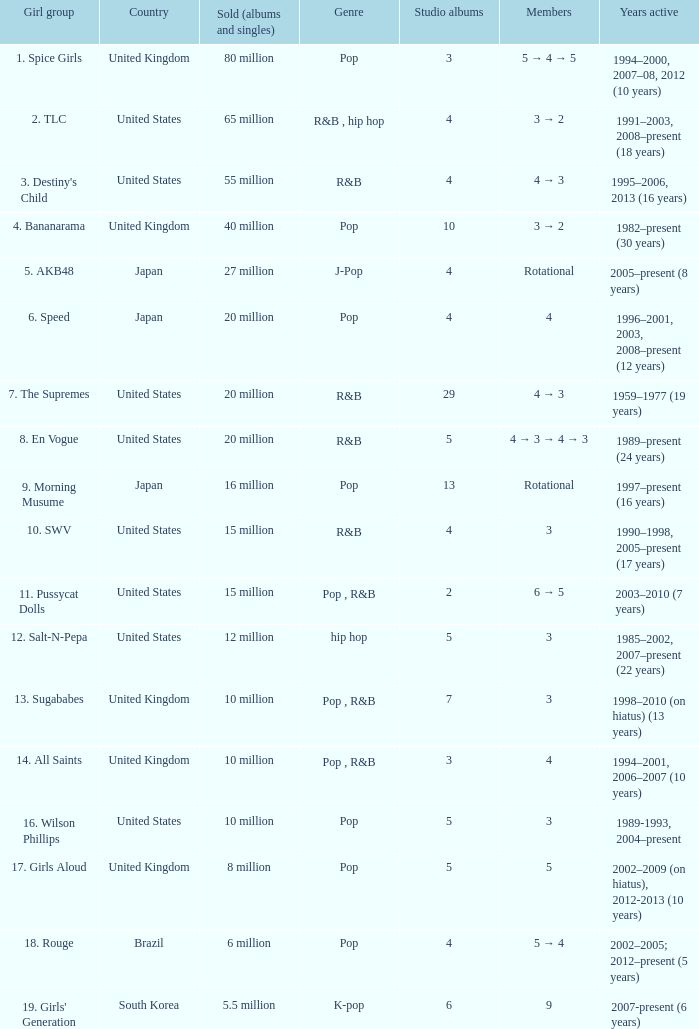What is the count of members in the band that sold 65 million albums and singles? 3 → 2. 